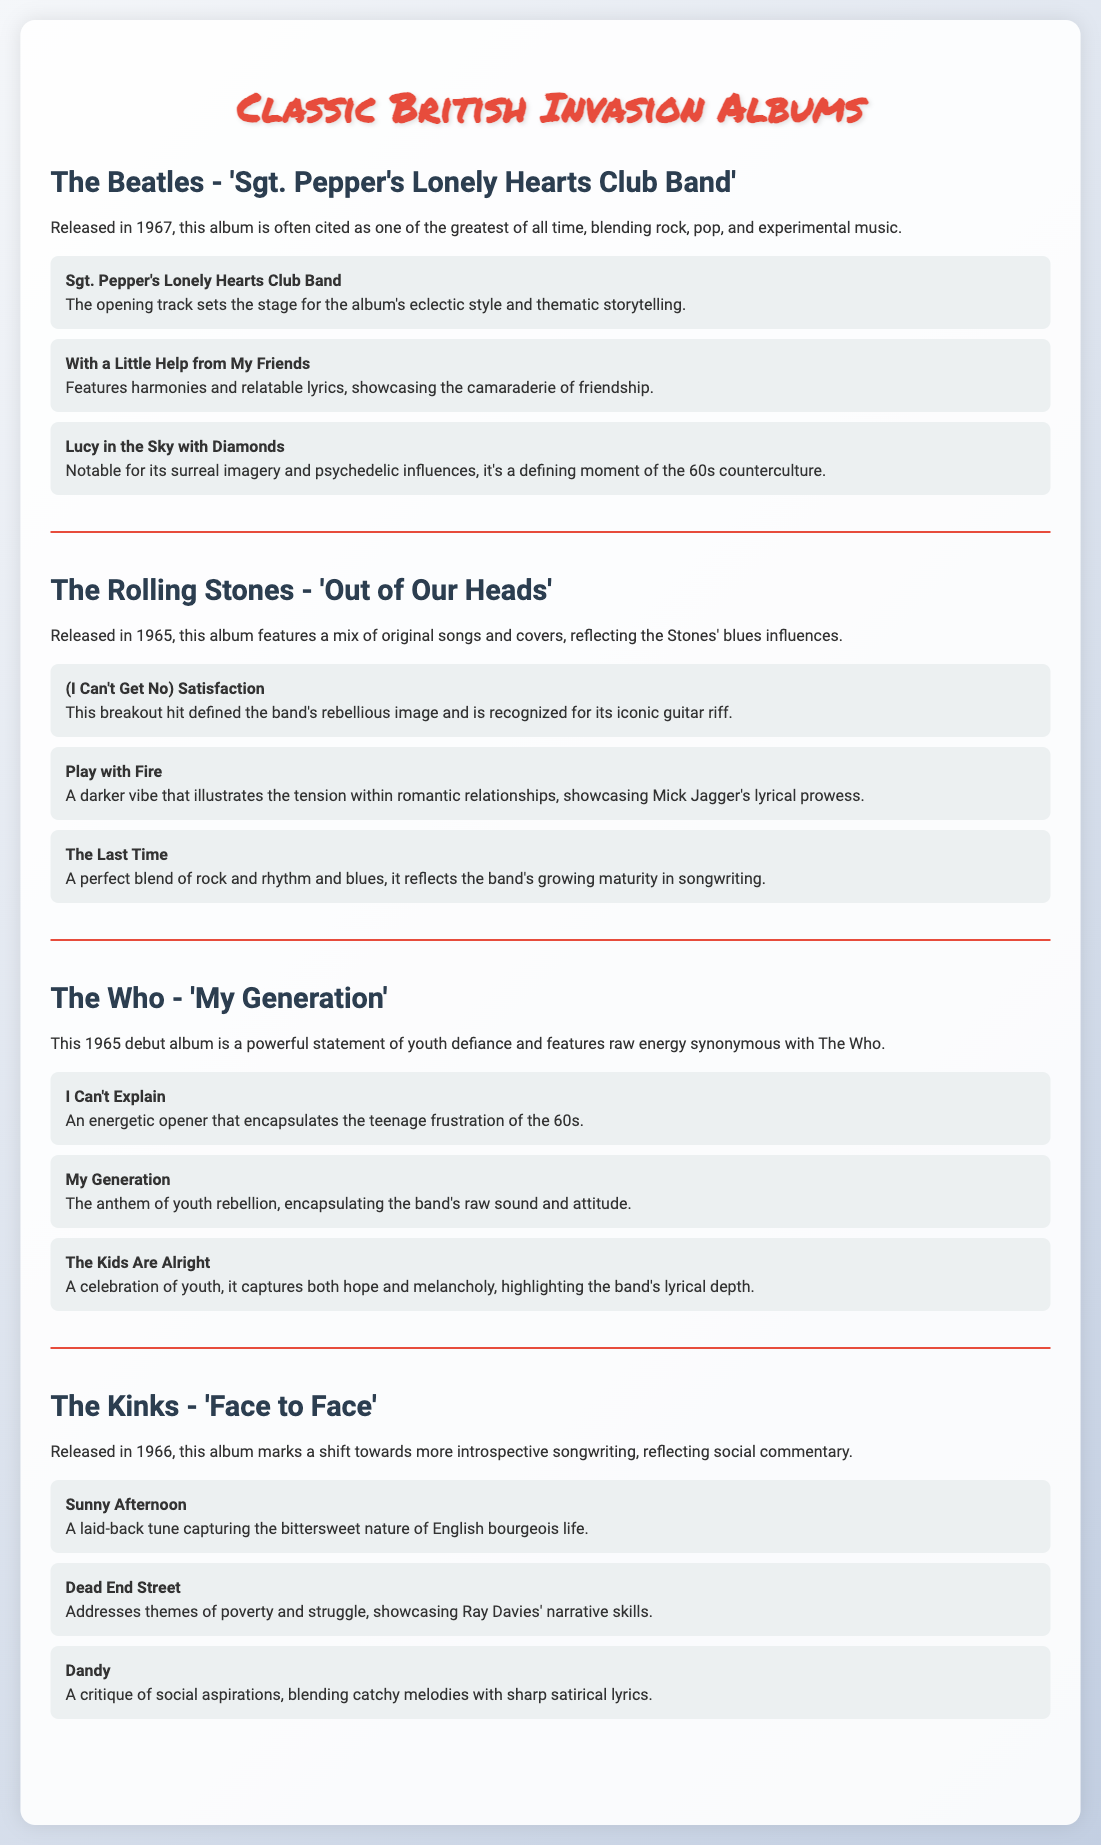What is the title of The Beatles' album released in 1967? The title listed is "Sgt. Pepper's Lonely Hearts Club Band," which is mentioned under The Beatles' section.
Answer: Sgt. Pepper's Lonely Hearts Club Band Which song from The Rolling Stones' album is recognized for its iconic guitar riff? The song is "(I Can't Get No) Satisfaction," as described in the track insights.
Answer: (I Can't Get No) Satisfaction What year was The Who's album 'My Generation' released? The document states that this album was released in 1965.
Answer: 1965 Which Kinks song addresses themes of poverty and struggle? The song mentioned is "Dead End Street," described in the Kinks' track insights.
Answer: Dead End Street What type of commentary does The Kinks’ album 'Face to Face' reflect? The album reflects social commentary, highlighting a shift towards introspective songwriting.
Answer: Social commentary Which band’s song is described as an anthem of youth rebellion? The song "My Generation" from The Who is highlighted as the anthem of youth rebellion.
Answer: My Generation What genre blend is noted in The Rolling Stones' album? The album features a mix of original songs and covers with blues influences.
Answer: Blues influences What is the overarching theme of The Beatles' album? The theme includes eclectic style and thematic storytelling as described in the overview.
Answer: Eclectic style and thematic storytelling 